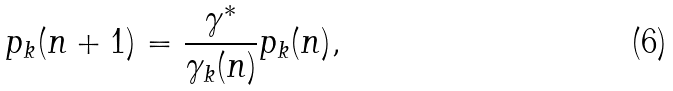Convert formula to latex. <formula><loc_0><loc_0><loc_500><loc_500>p _ { k } ( n + 1 ) = \frac { \gamma ^ { * } } { \gamma _ { k } ( n ) } p _ { k } ( n ) ,</formula> 